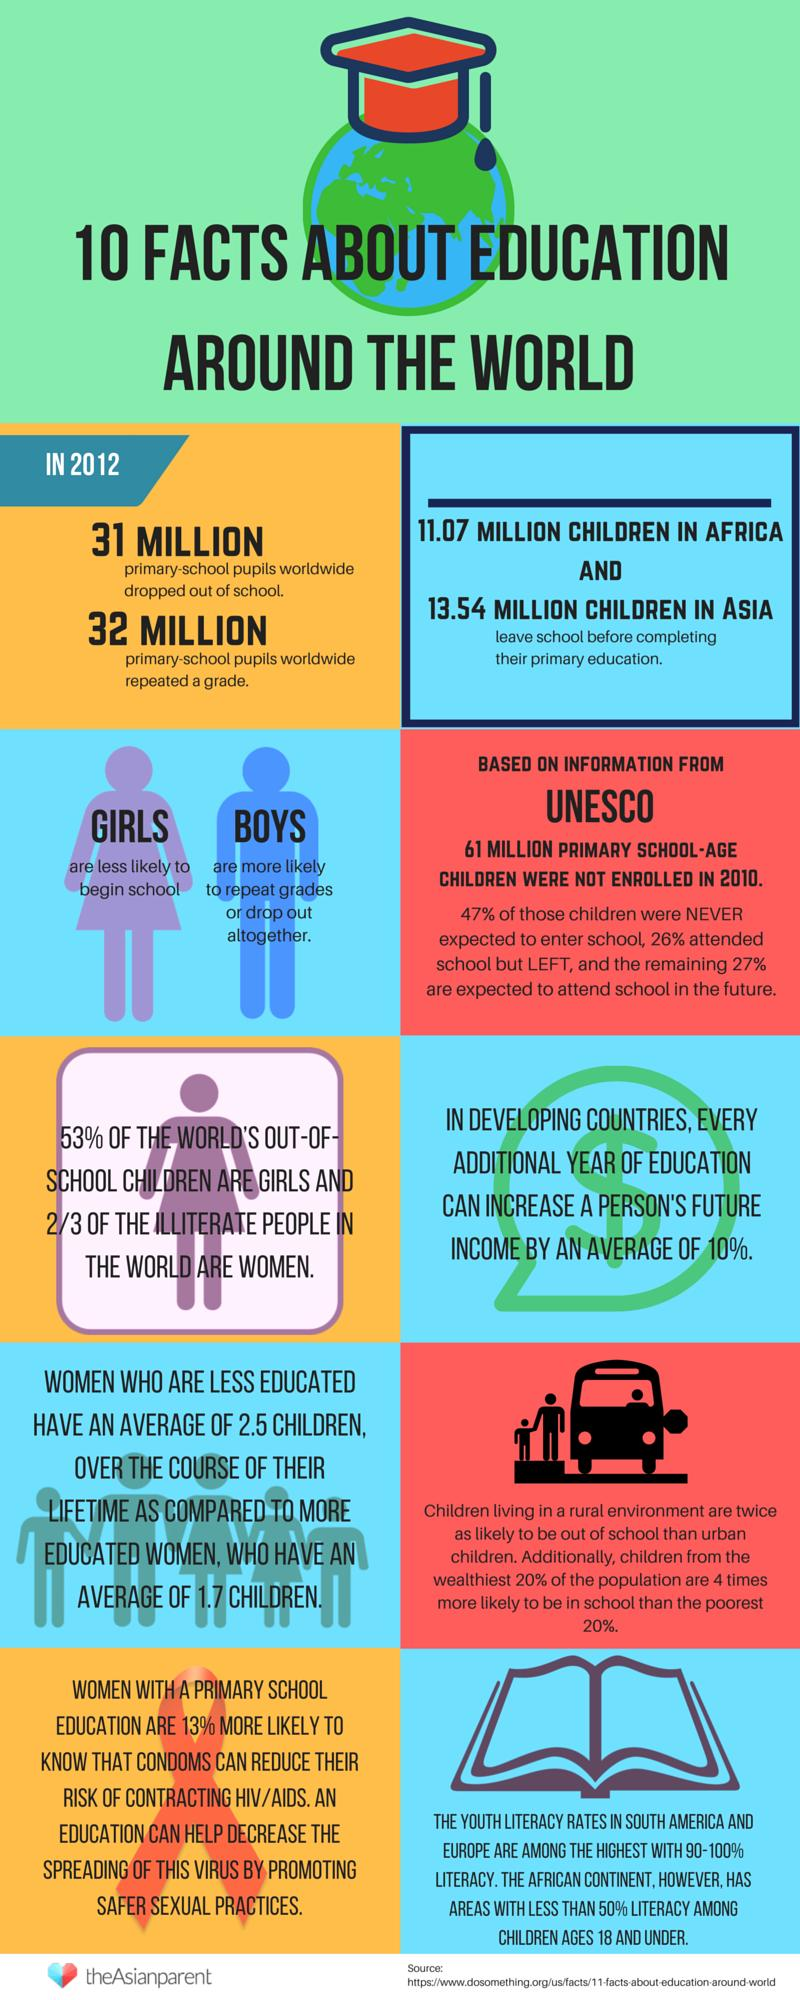List a handful of essential elements in this visual. The average number of children less educated women have is 0.8 less than the average number of children educated women have. According to recent studies, South America and Europe have the highest literacy rates among youths. This indicates that these two continents are making significant strides in providing education and promoting literacy among young people. It is important to note that these high literacy rates among youths are a positive indication of the overall development of these regions. 